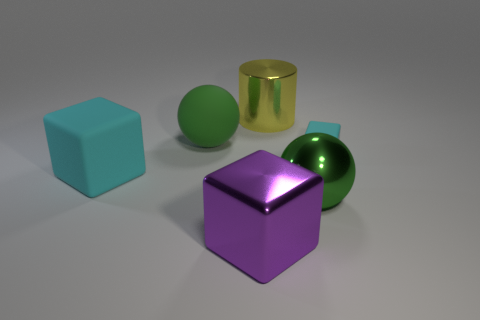Add 4 red balls. How many objects exist? 10 Subtract all balls. How many objects are left? 4 Add 2 large green rubber spheres. How many large green rubber spheres exist? 3 Subtract 0 cyan cylinders. How many objects are left? 6 Subtract all large yellow things. Subtract all small red cylinders. How many objects are left? 5 Add 3 green matte objects. How many green matte objects are left? 4 